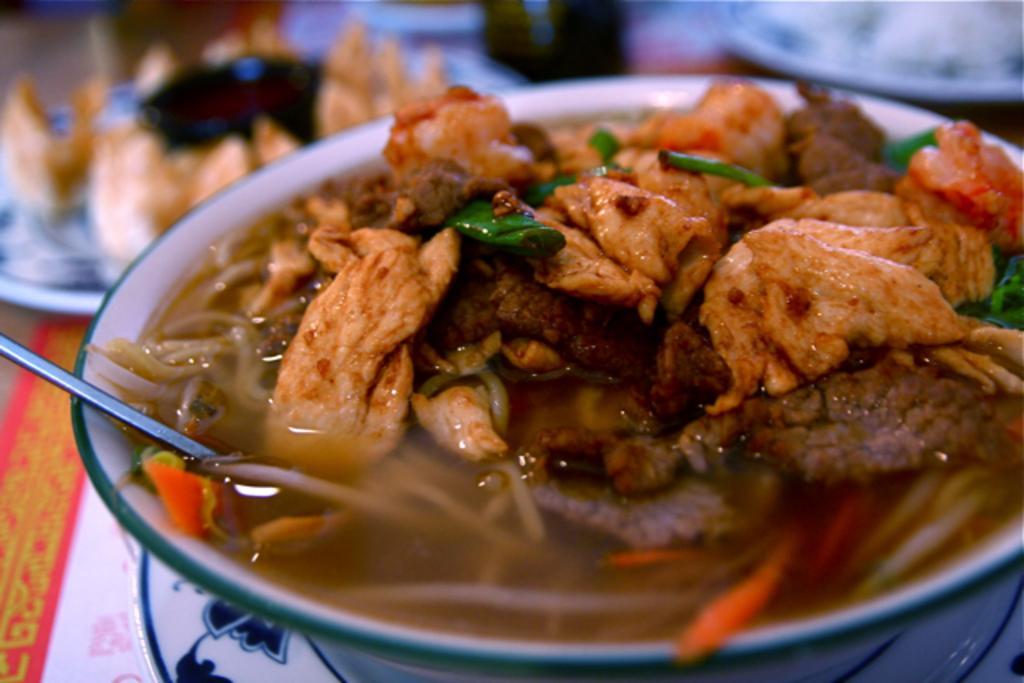Can you describe this image briefly? In this image I can see the food and the food is in brown, cream and green color. The food is in the bowl and the bowl is in white color and I can see blurred background. 